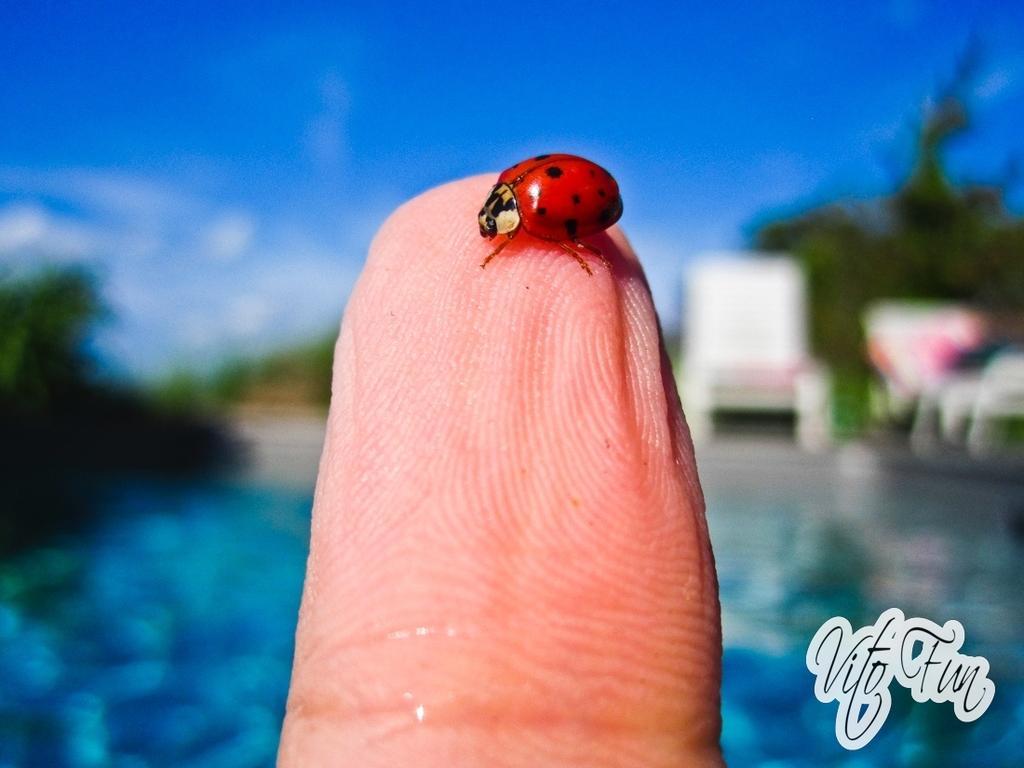Can you describe this image briefly? In this image, I can see a ladybird beetle on the fingertip. In the background, I can see the chair. I think this is a pool. I can see the watermark on the image. These are the trees. 